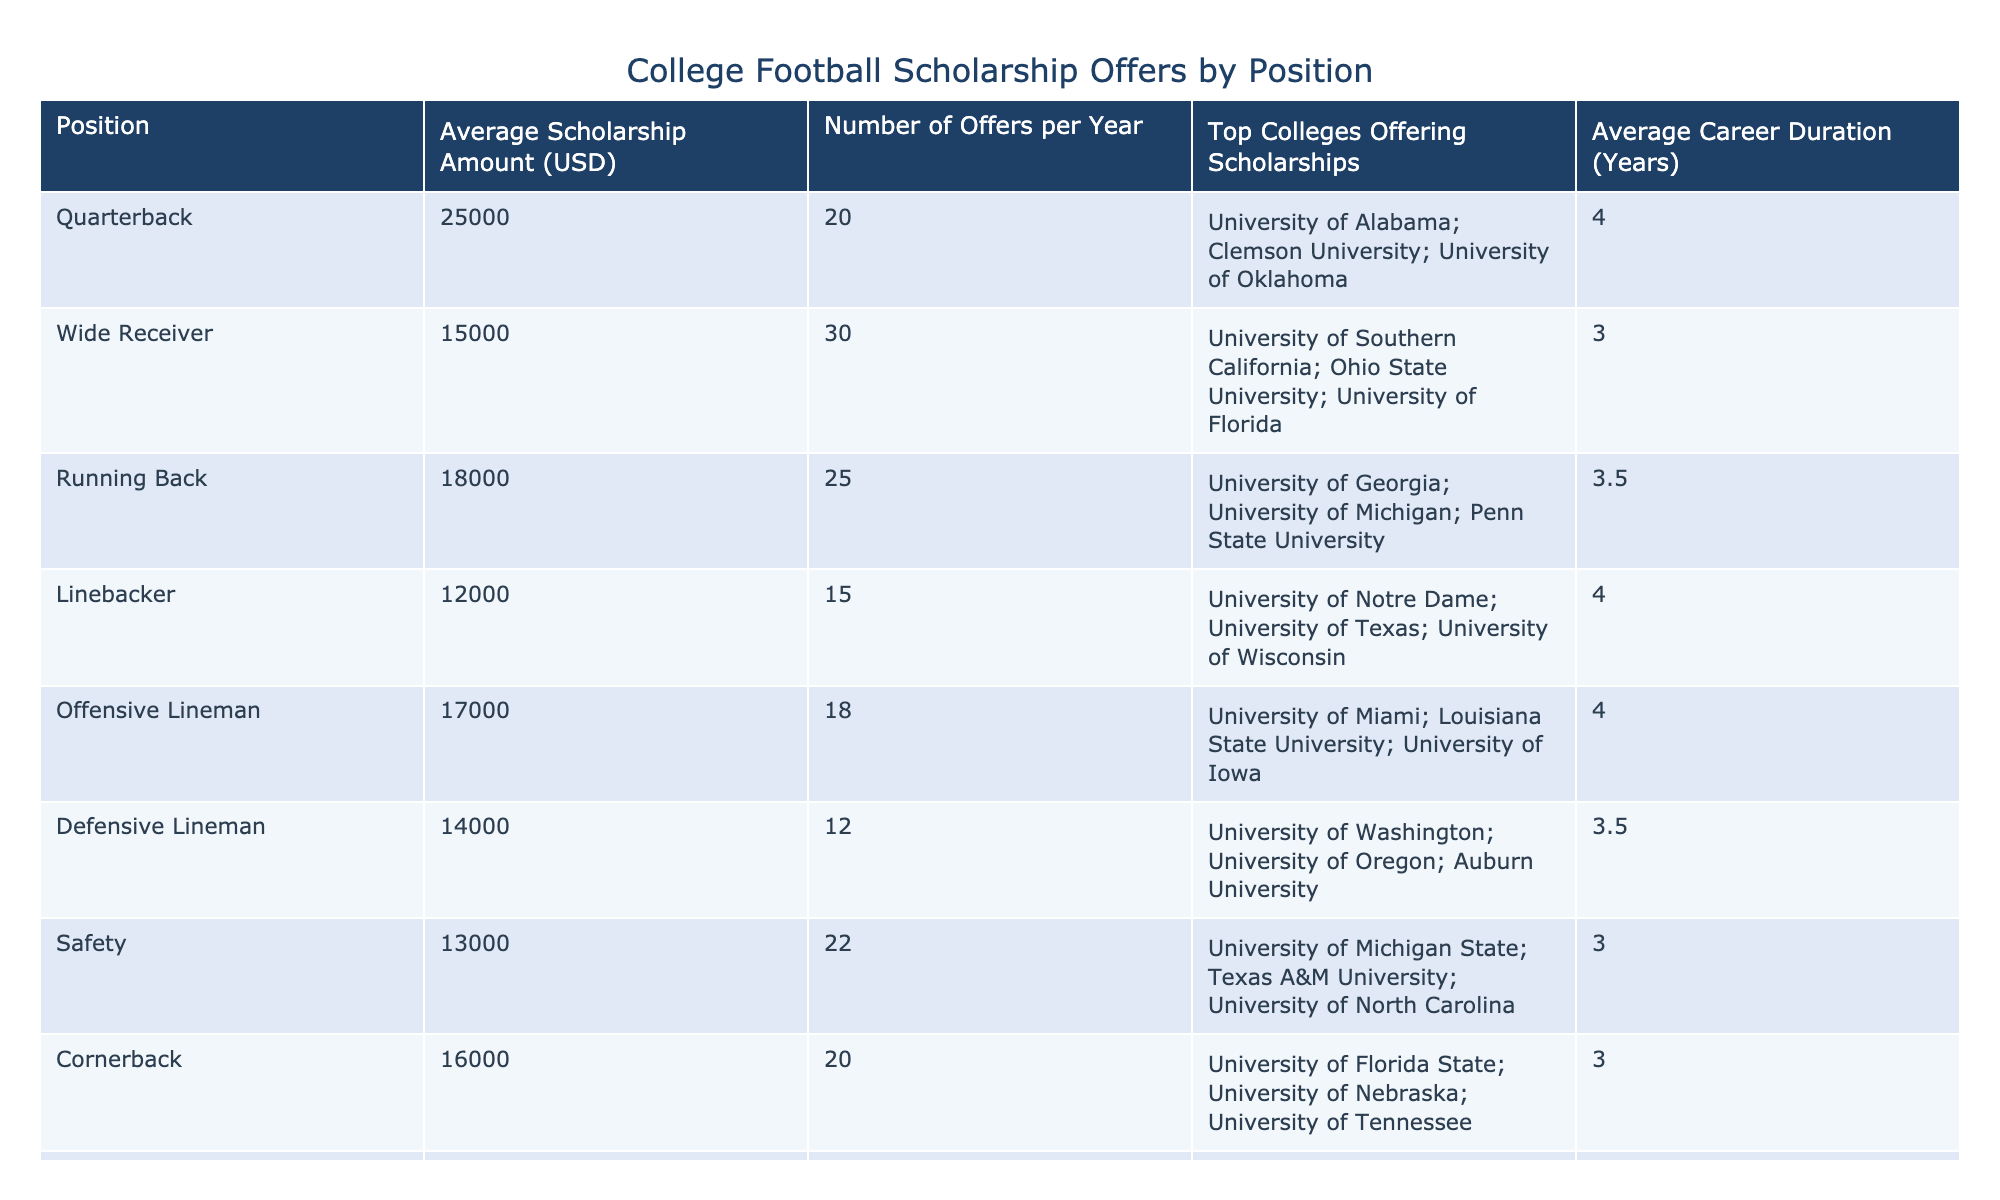What is the average scholarship amount for a Quarterback? The table shows that the average scholarship amount for a Quarterback is listed directly under the average scholarship amount column. It states $25,000.
Answer: $25,000 Which position has the highest number of scholarship offers per year? Looking at the 'Number of Offers per Year' column, the position with the highest value is Wide Receiver with 30 offers.
Answer: Wide Receiver How much more does a Tight End earn on average compared to a Kicker? The average scholarship for Tight Ends is $19,000 and for Kickers is $10,000. The difference is calculated as $19,000 - $10,000 = $9,000.
Answer: $9,000 What are the top colleges offering scholarships for Running Backs? The table lists the top colleges for Running Backs under the 'Top Colleges Offering Scholarships' column, which are University of Georgia, University of Michigan, and Penn State University.
Answer: University of Georgia, University of Michigan, Penn State University Is the average career duration for a Defensive Lineman longer than for a Kicker? The average career duration for a Defensive Lineman is 3.5 years, and for a Kicker, it is 2.5 years. Since 3.5 is greater than 2.5, the statement is true.
Answer: Yes Which position has the lowest average scholarship amount? Reviewing the 'Average Scholarship Amount (USD)' column, Kicker shows the lowest value at $10,000.
Answer: Kicker If we average the scholarship amounts of the Linebacker and Safety positions, what would that be? The average scholarship amount for Linebacker is $12,000 and for Safety is $13,000. The average is calculated as ($12,000 + $13,000) / 2 = $12,500.
Answer: $12,500 Which position has a higher average career duration, Cornerback or Wide Receiver? Cornerback's average career duration is 3 years, while Wide Receiver's is 3 years as well. Since both are equal, neither is longer.
Answer: Neither What is the total number of scholarship offers across all positions? Summing the number of offers per year for all positions yields 20 + 30 + 25 + 15 + 18 + 12 + 22 + 20 + 16 + 10 = 188 total offers.
Answer: 188 Are there more scholarship offers for Offensive Lineman than for Tight End? The table lists 18 offers for Offensive Lineman and 16 for Tight End, so there are more offers for Offensive Lineman.
Answer: Yes 